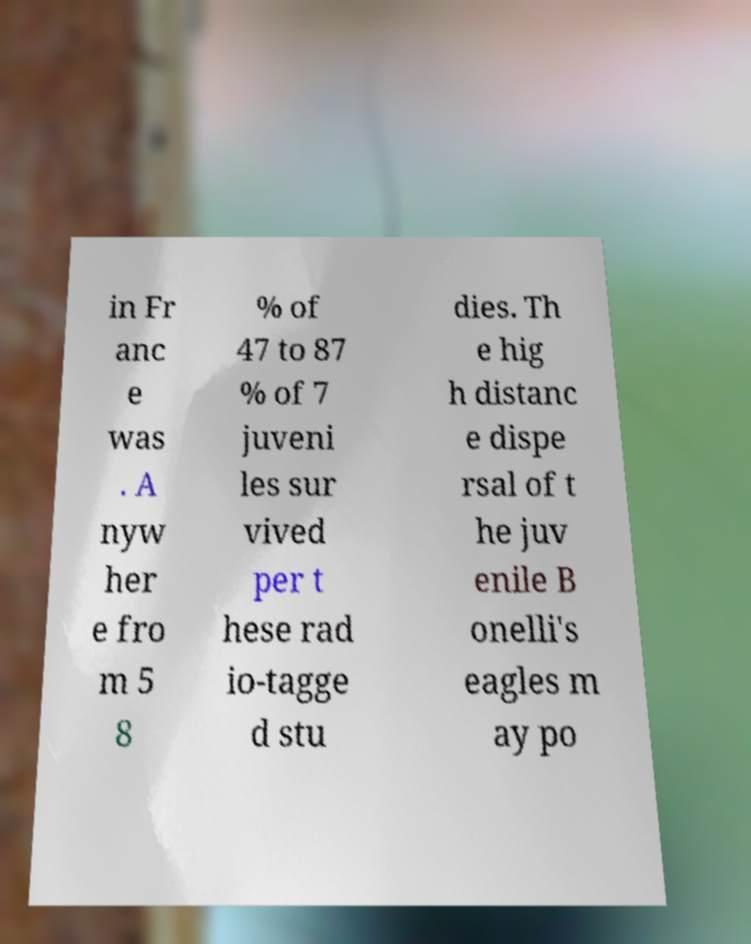There's text embedded in this image that I need extracted. Can you transcribe it verbatim? in Fr anc e was . A nyw her e fro m 5 8 % of 47 to 87 % of 7 juveni les sur vived per t hese rad io-tagge d stu dies. Th e hig h distanc e dispe rsal of t he juv enile B onelli's eagles m ay po 